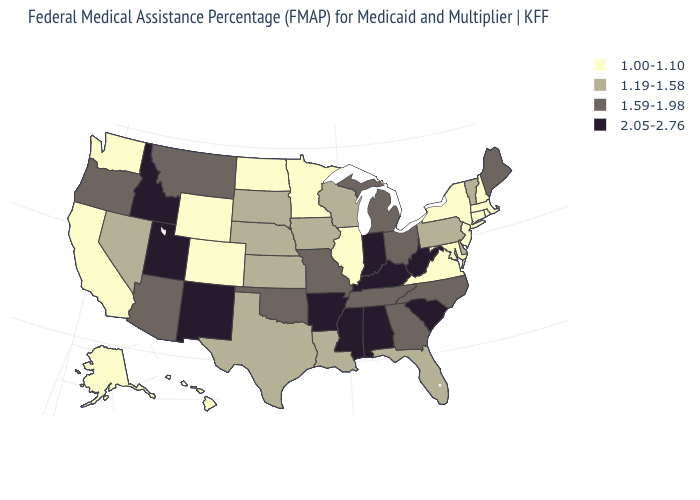Does Idaho have a higher value than California?
Keep it brief. Yes. Name the states that have a value in the range 1.00-1.10?
Quick response, please. Alaska, California, Colorado, Connecticut, Hawaii, Illinois, Maryland, Massachusetts, Minnesota, New Hampshire, New Jersey, New York, North Dakota, Rhode Island, Virginia, Washington, Wyoming. Name the states that have a value in the range 1.19-1.58?
Answer briefly. Delaware, Florida, Iowa, Kansas, Louisiana, Nebraska, Nevada, Pennsylvania, South Dakota, Texas, Vermont, Wisconsin. Which states have the highest value in the USA?
Give a very brief answer. Alabama, Arkansas, Idaho, Indiana, Kentucky, Mississippi, New Mexico, South Carolina, Utah, West Virginia. What is the value of Oklahoma?
Give a very brief answer. 1.59-1.98. Does West Virginia have the highest value in the USA?
Concise answer only. Yes. What is the lowest value in the USA?
Write a very short answer. 1.00-1.10. How many symbols are there in the legend?
Answer briefly. 4. Does North Carolina have the highest value in the USA?
Be succinct. No. Name the states that have a value in the range 1.19-1.58?
Write a very short answer. Delaware, Florida, Iowa, Kansas, Louisiana, Nebraska, Nevada, Pennsylvania, South Dakota, Texas, Vermont, Wisconsin. What is the value of Hawaii?
Short answer required. 1.00-1.10. What is the value of New Mexico?
Concise answer only. 2.05-2.76. Does Massachusetts have the same value as Wyoming?
Keep it brief. Yes. Name the states that have a value in the range 1.00-1.10?
Answer briefly. Alaska, California, Colorado, Connecticut, Hawaii, Illinois, Maryland, Massachusetts, Minnesota, New Hampshire, New Jersey, New York, North Dakota, Rhode Island, Virginia, Washington, Wyoming. What is the value of Nebraska?
Write a very short answer. 1.19-1.58. 